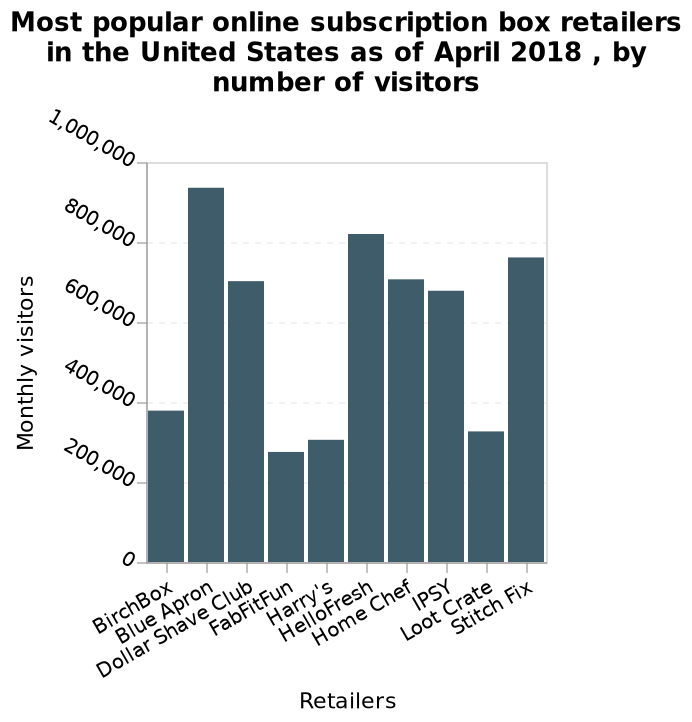<image>
Which online subscription box retailer is labeled on one end of the x-axis? BirchBox Which companies had over 600,000 monthly visitors? All companies except Birchbox, FabFitFun, Harry's, and Loot crate had over 600,000 monthly visitors. 